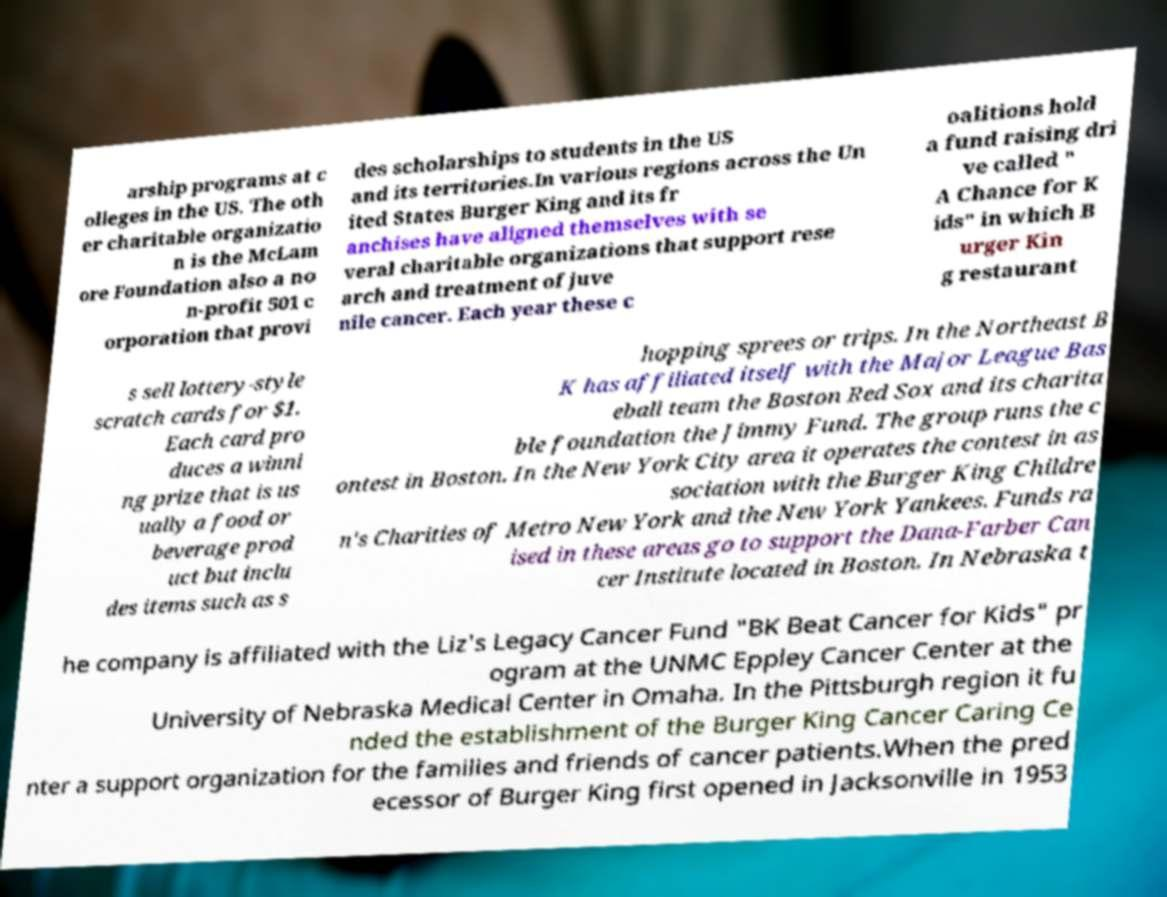Can you accurately transcribe the text from the provided image for me? arship programs at c olleges in the US. The oth er charitable organizatio n is the McLam ore Foundation also a no n-profit 501 c orporation that provi des scholarships to students in the US and its territories.In various regions across the Un ited States Burger King and its fr anchises have aligned themselves with se veral charitable organizations that support rese arch and treatment of juve nile cancer. Each year these c oalitions hold a fund raising dri ve called " A Chance for K ids" in which B urger Kin g restaurant s sell lottery-style scratch cards for $1. Each card pro duces a winni ng prize that is us ually a food or beverage prod uct but inclu des items such as s hopping sprees or trips. In the Northeast B K has affiliated itself with the Major League Bas eball team the Boston Red Sox and its charita ble foundation the Jimmy Fund. The group runs the c ontest in Boston. In the New York City area it operates the contest in as sociation with the Burger King Childre n's Charities of Metro New York and the New York Yankees. Funds ra ised in these areas go to support the Dana-Farber Can cer Institute located in Boston. In Nebraska t he company is affiliated with the Liz's Legacy Cancer Fund "BK Beat Cancer for Kids" pr ogram at the UNMC Eppley Cancer Center at the University of Nebraska Medical Center in Omaha. In the Pittsburgh region it fu nded the establishment of the Burger King Cancer Caring Ce nter a support organization for the families and friends of cancer patients.When the pred ecessor of Burger King first opened in Jacksonville in 1953 